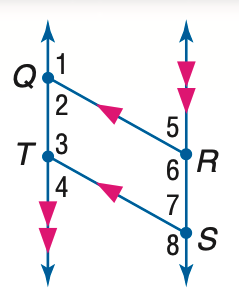Answer the mathemtical geometry problem and directly provide the correct option letter.
Question: In the figure, Q R \parallel T S, Q T \parallel R S, and m \angle 1 = 131. Find the measure of \angle 2.
Choices: A: 49 B: 59 C: 69 D: 131 A 